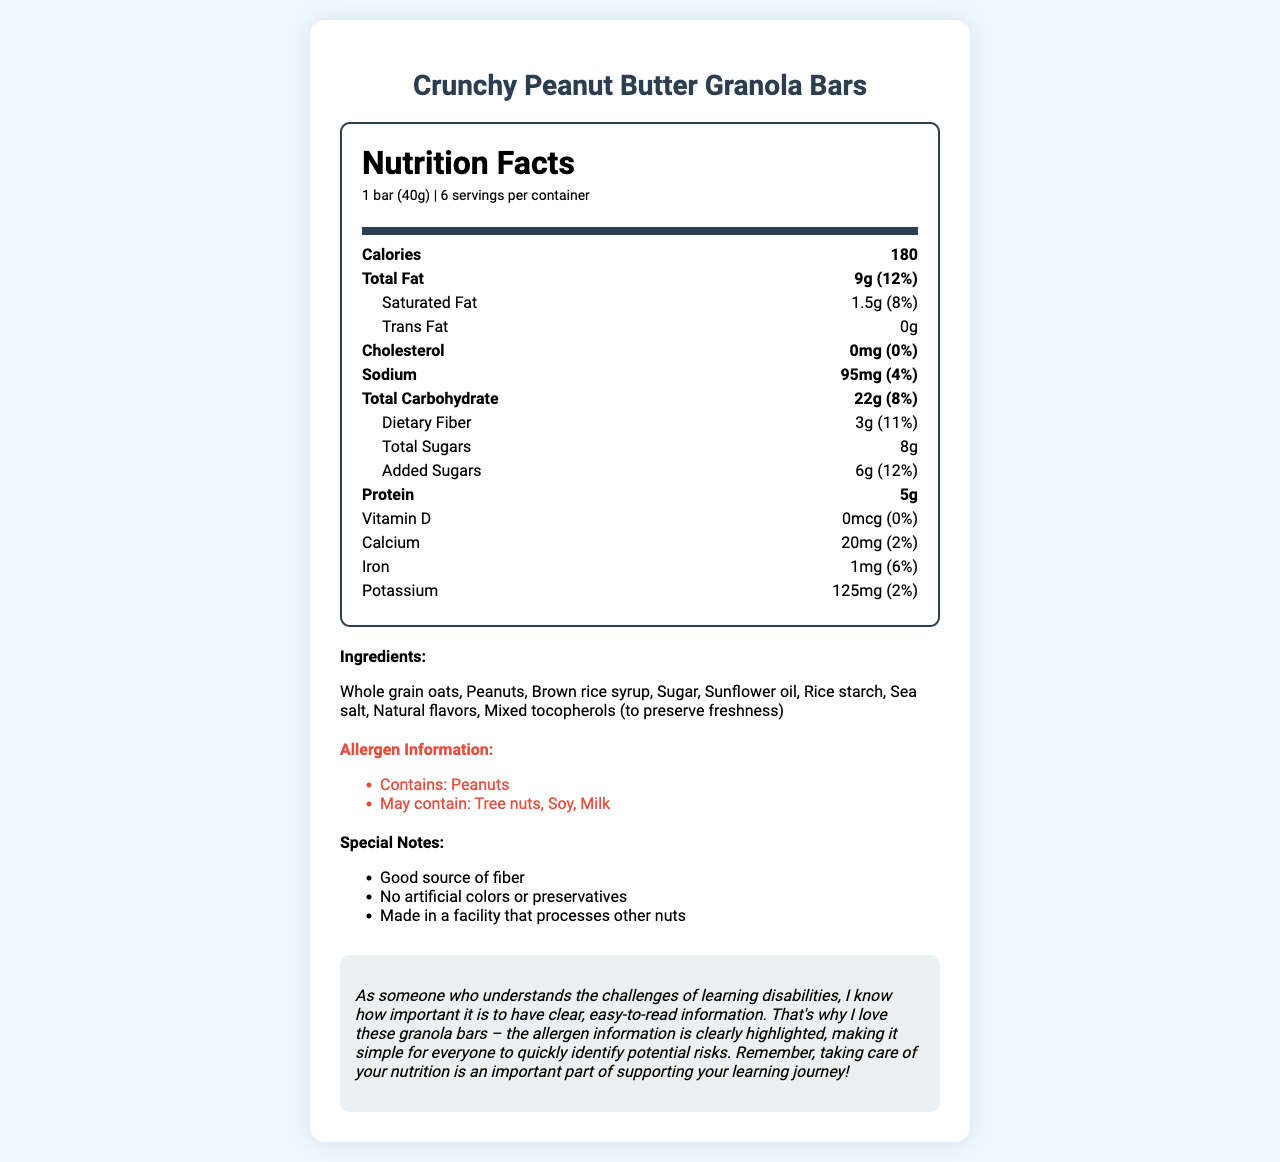what is the product name? The name of the product is stated at the top of the document as "Crunchy Peanut Butter Granola Bars".
Answer: Crunchy Peanut Butter Granola Bars how many calories are in one serving? The calorie count per serving is listed as 180 under the nutrition facts section.
Answer: 180 what is the serving size? The serving size is stated as "1 bar (40g)" in the nutrition facts section.
Answer: 1 bar (40g) how much protein is in one serving? The amount of protein per serving is listed as 5g in the nutrition facts section.
Answer: 5g what allergens are highlighted in this product? The allergen information is highlighted and lists "Contains: Peanuts" and "May contain: Tree nuts, Soy, Milk".
Answer: Contains: Peanuts; May contain: Tree nuts, Soy, Milk which of these nutrients has the highest percent daily value? A. Saturated Fat B. Dietary Fiber C. Calcium D. Iron Saturated fat has 8% daily value, higher than dietary fiber (11%), calcium (2%), and iron (6%).
Answer: A. Saturated Fat what is the amount of added sugars per serving? The amount of added sugars per serving is specified as 6g.
Answer: 6g is there any cholesterol in the product? The document indicates that the cholesterol amount is 0mg, which means there is no cholesterol.
Answer: No describe the special notes provided about the product. The special notes section details three important points: good source of fiber, no artificial colors or preservatives, and made in a facility that processes other nuts.
Answer: The product is a good source of fiber, contains no artificial colors or preservatives, and is made in a facility that processes other nuts. what is the percent daily value of potassium? The percent daily value of potassium is listed as 2% in the nutrition facts section.
Answer: 2% how many serving sizes are there in one container? The document states there are 6 servings per container.
Answer: 6 which ingredient helps to preserve freshness? A. Whole grain oats B. Brown rice syrup C. Sunflower oil D. Mixed tocopherols Mixed tocopherols are listed in the ingredients section with the note "to preserve freshness".
Answer: D. Mixed tocopherols which ingredient is not mentioned in the ingredient list? Honey is not listed among the ingredients in the document.
Answer: Honey do these granola bars contain artificial preservatives? The special notes section mentions "No artificial colors or preservatives".
Answer: No what is the main idea of the document? The document details all relevant information about Crunchy Peanut Butter Granola Bars, including nutrition content, ingredient list, allergen warnings, and additional special notes, alongside a personalized message about the importance of clear labeling.
Answer: The document provides the nutrition facts, ingredients, allergen information, and special notes for Crunchy Peanut Butter Granola Bars with a personalized message emphasizing the importance of clear information for those with learning disabilities. 